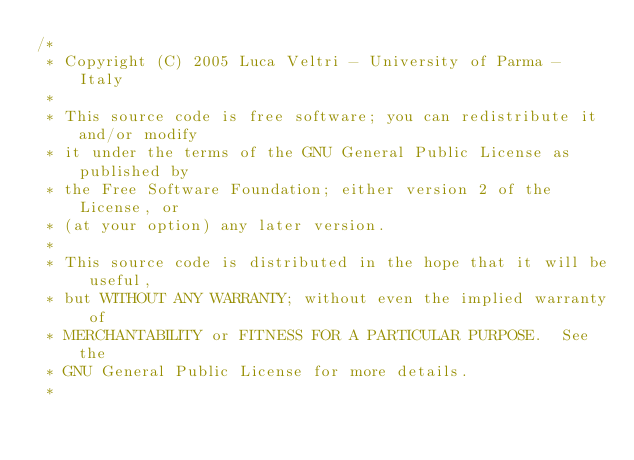<code> <loc_0><loc_0><loc_500><loc_500><_Java_>/*
 * Copyright (C) 2005 Luca Veltri - University of Parma - Italy
 * 
 * This source code is free software; you can redistribute it and/or modify
 * it under the terms of the GNU General Public License as published by
 * the Free Software Foundation; either version 2 of the License, or
 * (at your option) any later version.
 * 
 * This source code is distributed in the hope that it will be useful,
 * but WITHOUT ANY WARRANTY; without even the implied warranty of
 * MERCHANTABILITY or FITNESS FOR A PARTICULAR PURPOSE.  See the
 * GNU General Public License for more details.
 * </code> 